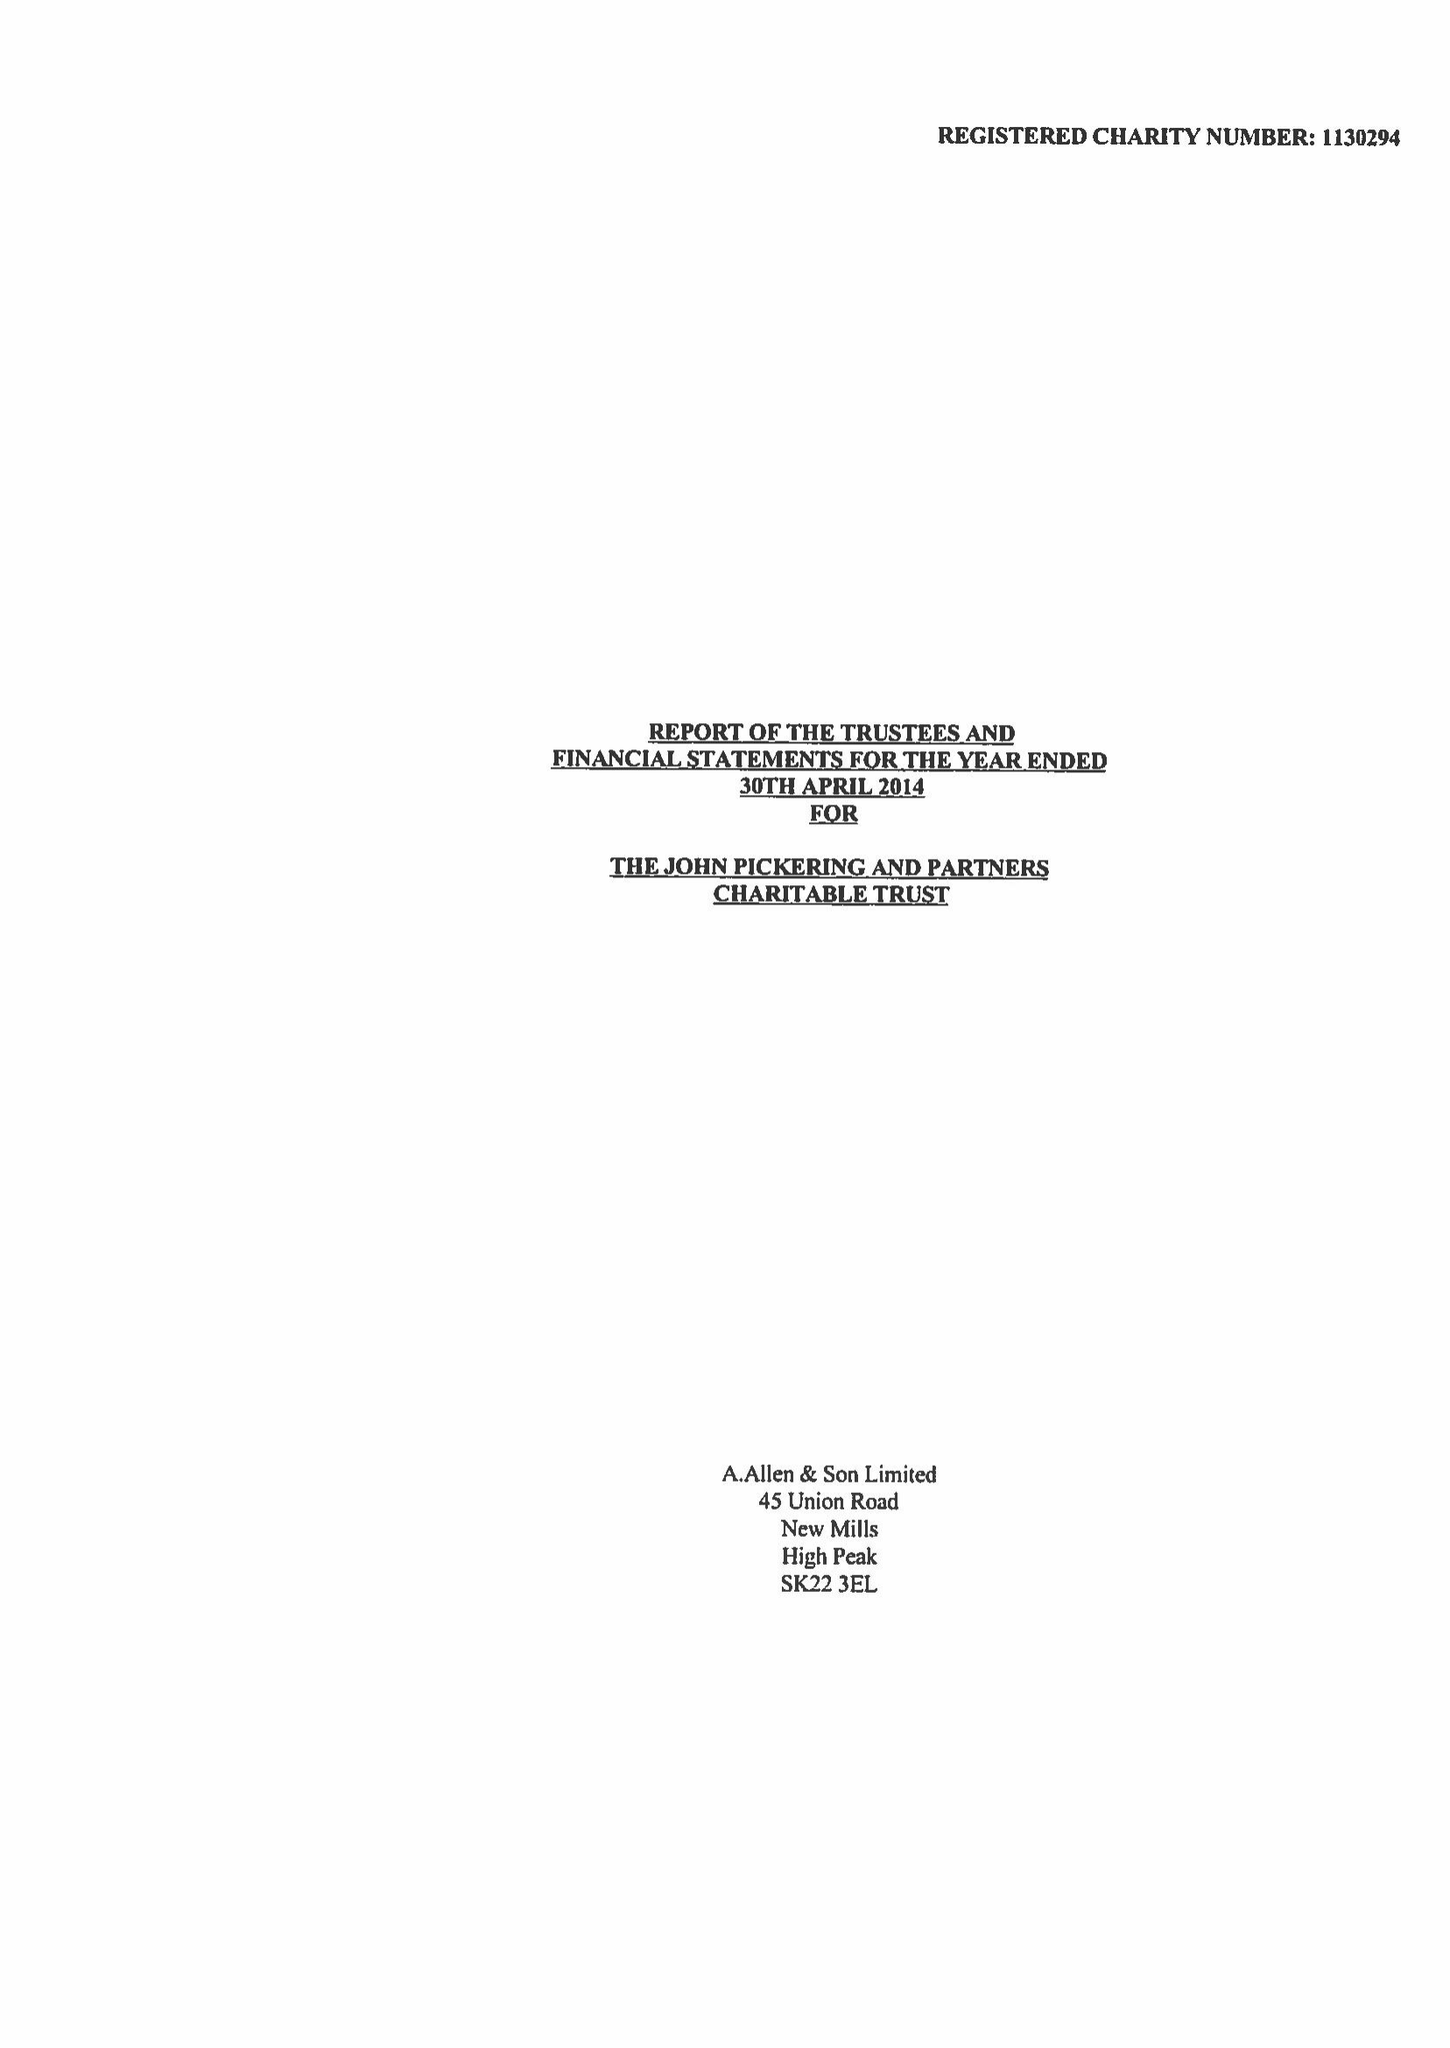What is the value for the spending_annually_in_british_pounds?
Answer the question using a single word or phrase. None 